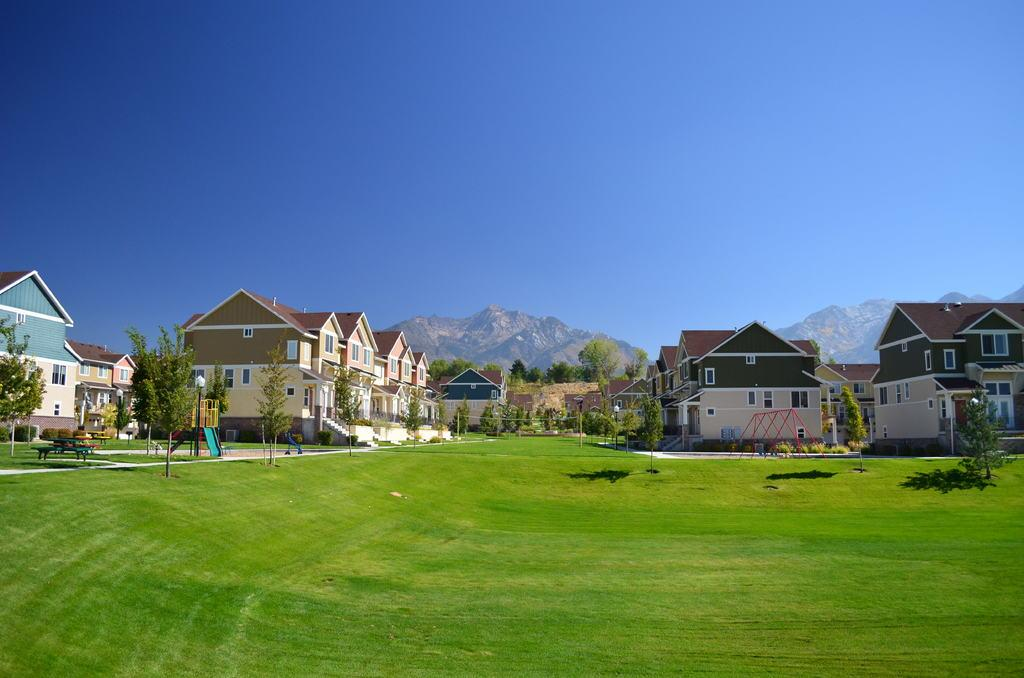What type of vegetation can be seen in the image? There are trees in the image. What type of structures are visible in the image? There are buildings in the image. What natural landforms can be seen in the image? There are mountains in the image. What type of ground cover is present in the image? There is grass on the ground in the image. What is visible at the top of the image? The sky is visible at the top of the image. How many deer are present in the image? There are no deer present in the image. What type of disease can be seen affecting the trees in the image? There is no disease affecting the trees in the image; the trees appear healthy. 